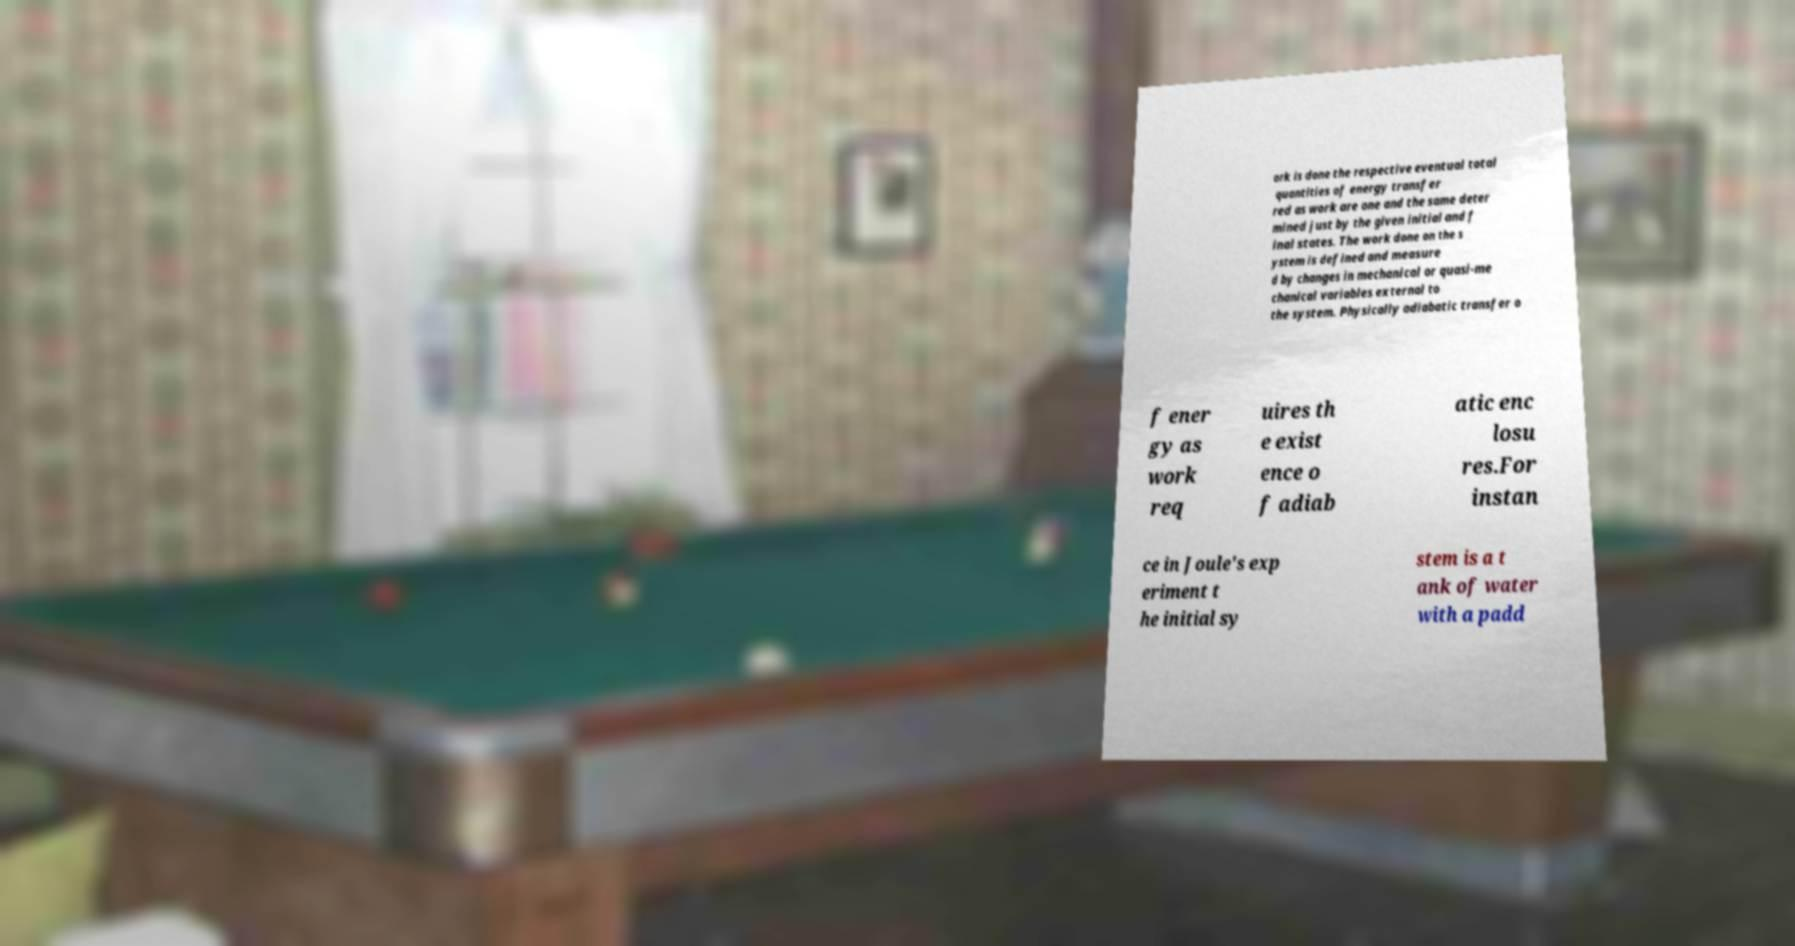Could you assist in decoding the text presented in this image and type it out clearly? ork is done the respective eventual total quantities of energy transfer red as work are one and the same deter mined just by the given initial and f inal states. The work done on the s ystem is defined and measure d by changes in mechanical or quasi-me chanical variables external to the system. Physically adiabatic transfer o f ener gy as work req uires th e exist ence o f adiab atic enc losu res.For instan ce in Joule's exp eriment t he initial sy stem is a t ank of water with a padd 